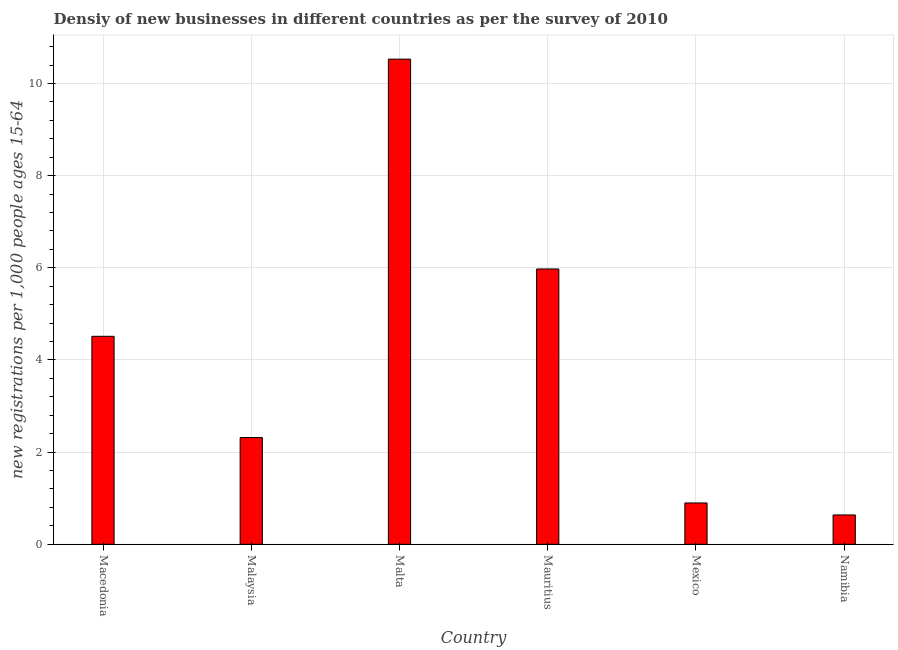Does the graph contain any zero values?
Your answer should be very brief. No. What is the title of the graph?
Keep it short and to the point. Densiy of new businesses in different countries as per the survey of 2010. What is the label or title of the Y-axis?
Make the answer very short. New registrations per 1,0 people ages 15-64. What is the density of new business in Namibia?
Make the answer very short. 0.64. Across all countries, what is the maximum density of new business?
Ensure brevity in your answer.  10.53. Across all countries, what is the minimum density of new business?
Give a very brief answer. 0.64. In which country was the density of new business maximum?
Provide a short and direct response. Malta. In which country was the density of new business minimum?
Provide a short and direct response. Namibia. What is the sum of the density of new business?
Offer a very short reply. 24.87. What is the difference between the density of new business in Malta and Mauritius?
Provide a succinct answer. 4.55. What is the average density of new business per country?
Your answer should be very brief. 4.14. What is the median density of new business?
Keep it short and to the point. 3.42. What is the ratio of the density of new business in Mexico to that in Namibia?
Your answer should be very brief. 1.41. Is the difference between the density of new business in Malta and Mauritius greater than the difference between any two countries?
Keep it short and to the point. No. What is the difference between the highest and the second highest density of new business?
Ensure brevity in your answer.  4.55. What is the difference between the highest and the lowest density of new business?
Provide a succinct answer. 9.89. How many bars are there?
Keep it short and to the point. 6. How many countries are there in the graph?
Keep it short and to the point. 6. What is the new registrations per 1,000 people ages 15-64 of Macedonia?
Make the answer very short. 4.51. What is the new registrations per 1,000 people ages 15-64 in Malaysia?
Make the answer very short. 2.32. What is the new registrations per 1,000 people ages 15-64 in Malta?
Offer a terse response. 10.53. What is the new registrations per 1,000 people ages 15-64 of Mauritius?
Give a very brief answer. 5.97. What is the new registrations per 1,000 people ages 15-64 of Mexico?
Provide a short and direct response. 0.9. What is the new registrations per 1,000 people ages 15-64 in Namibia?
Your answer should be compact. 0.64. What is the difference between the new registrations per 1,000 people ages 15-64 in Macedonia and Malaysia?
Offer a very short reply. 2.2. What is the difference between the new registrations per 1,000 people ages 15-64 in Macedonia and Malta?
Your answer should be compact. -6.02. What is the difference between the new registrations per 1,000 people ages 15-64 in Macedonia and Mauritius?
Ensure brevity in your answer.  -1.46. What is the difference between the new registrations per 1,000 people ages 15-64 in Macedonia and Mexico?
Provide a short and direct response. 3.62. What is the difference between the new registrations per 1,000 people ages 15-64 in Macedonia and Namibia?
Keep it short and to the point. 3.88. What is the difference between the new registrations per 1,000 people ages 15-64 in Malaysia and Malta?
Make the answer very short. -8.21. What is the difference between the new registrations per 1,000 people ages 15-64 in Malaysia and Mauritius?
Provide a succinct answer. -3.66. What is the difference between the new registrations per 1,000 people ages 15-64 in Malaysia and Mexico?
Your answer should be very brief. 1.42. What is the difference between the new registrations per 1,000 people ages 15-64 in Malaysia and Namibia?
Your response must be concise. 1.68. What is the difference between the new registrations per 1,000 people ages 15-64 in Malta and Mauritius?
Your response must be concise. 4.55. What is the difference between the new registrations per 1,000 people ages 15-64 in Malta and Mexico?
Provide a short and direct response. 9.63. What is the difference between the new registrations per 1,000 people ages 15-64 in Malta and Namibia?
Provide a short and direct response. 9.89. What is the difference between the new registrations per 1,000 people ages 15-64 in Mauritius and Mexico?
Your answer should be compact. 5.08. What is the difference between the new registrations per 1,000 people ages 15-64 in Mauritius and Namibia?
Keep it short and to the point. 5.34. What is the difference between the new registrations per 1,000 people ages 15-64 in Mexico and Namibia?
Your answer should be compact. 0.26. What is the ratio of the new registrations per 1,000 people ages 15-64 in Macedonia to that in Malaysia?
Give a very brief answer. 1.95. What is the ratio of the new registrations per 1,000 people ages 15-64 in Macedonia to that in Malta?
Keep it short and to the point. 0.43. What is the ratio of the new registrations per 1,000 people ages 15-64 in Macedonia to that in Mauritius?
Ensure brevity in your answer.  0.76. What is the ratio of the new registrations per 1,000 people ages 15-64 in Macedonia to that in Mexico?
Your answer should be compact. 5.03. What is the ratio of the new registrations per 1,000 people ages 15-64 in Macedonia to that in Namibia?
Provide a succinct answer. 7.09. What is the ratio of the new registrations per 1,000 people ages 15-64 in Malaysia to that in Malta?
Offer a very short reply. 0.22. What is the ratio of the new registrations per 1,000 people ages 15-64 in Malaysia to that in Mauritius?
Your answer should be very brief. 0.39. What is the ratio of the new registrations per 1,000 people ages 15-64 in Malaysia to that in Mexico?
Your answer should be compact. 2.58. What is the ratio of the new registrations per 1,000 people ages 15-64 in Malaysia to that in Namibia?
Your answer should be compact. 3.64. What is the ratio of the new registrations per 1,000 people ages 15-64 in Malta to that in Mauritius?
Offer a very short reply. 1.76. What is the ratio of the new registrations per 1,000 people ages 15-64 in Malta to that in Mexico?
Your answer should be compact. 11.74. What is the ratio of the new registrations per 1,000 people ages 15-64 in Malta to that in Namibia?
Provide a short and direct response. 16.53. What is the ratio of the new registrations per 1,000 people ages 15-64 in Mauritius to that in Mexico?
Your answer should be compact. 6.66. What is the ratio of the new registrations per 1,000 people ages 15-64 in Mauritius to that in Namibia?
Your response must be concise. 9.38. What is the ratio of the new registrations per 1,000 people ages 15-64 in Mexico to that in Namibia?
Your answer should be very brief. 1.41. 